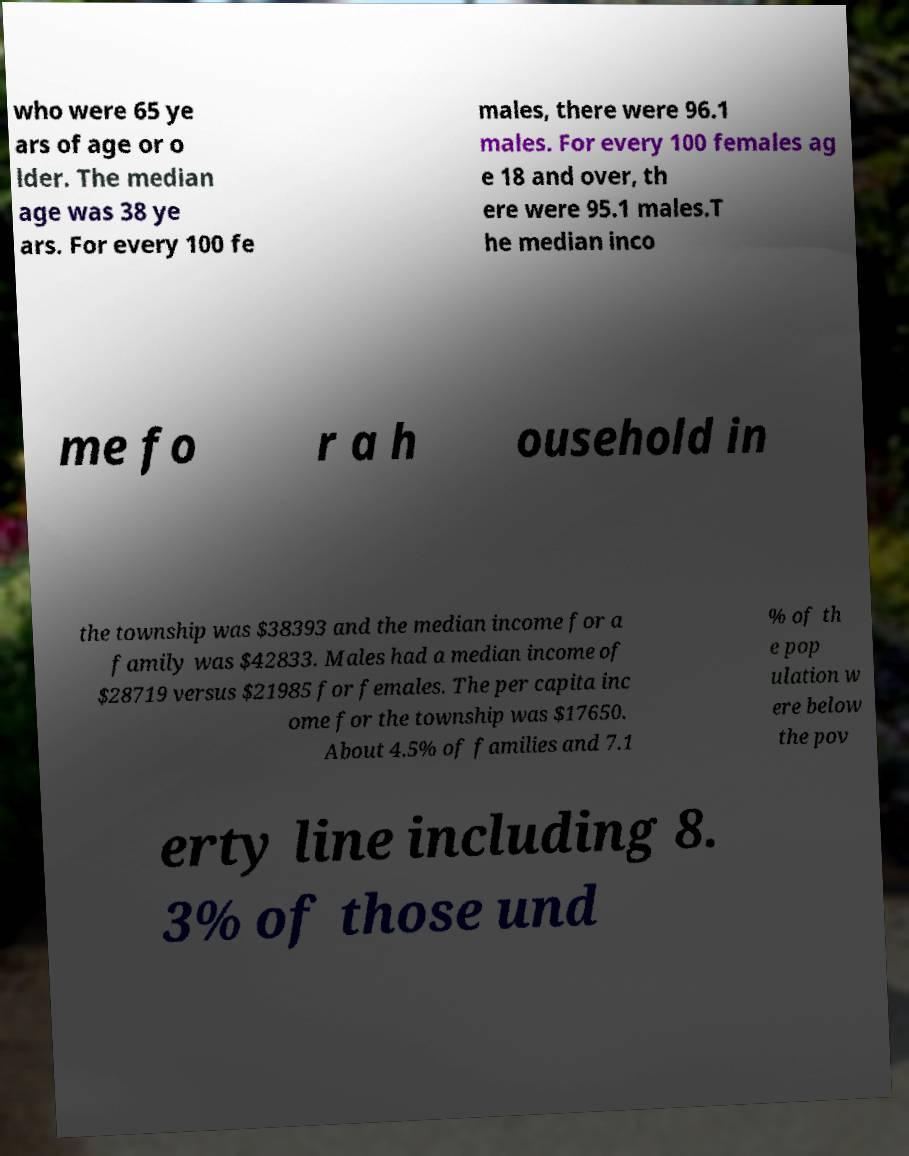Please identify and transcribe the text found in this image. who were 65 ye ars of age or o lder. The median age was 38 ye ars. For every 100 fe males, there were 96.1 males. For every 100 females ag e 18 and over, th ere were 95.1 males.T he median inco me fo r a h ousehold in the township was $38393 and the median income for a family was $42833. Males had a median income of $28719 versus $21985 for females. The per capita inc ome for the township was $17650. About 4.5% of families and 7.1 % of th e pop ulation w ere below the pov erty line including 8. 3% of those und 